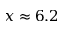Convert formula to latex. <formula><loc_0><loc_0><loc_500><loc_500>x \approx 6 . 2</formula> 